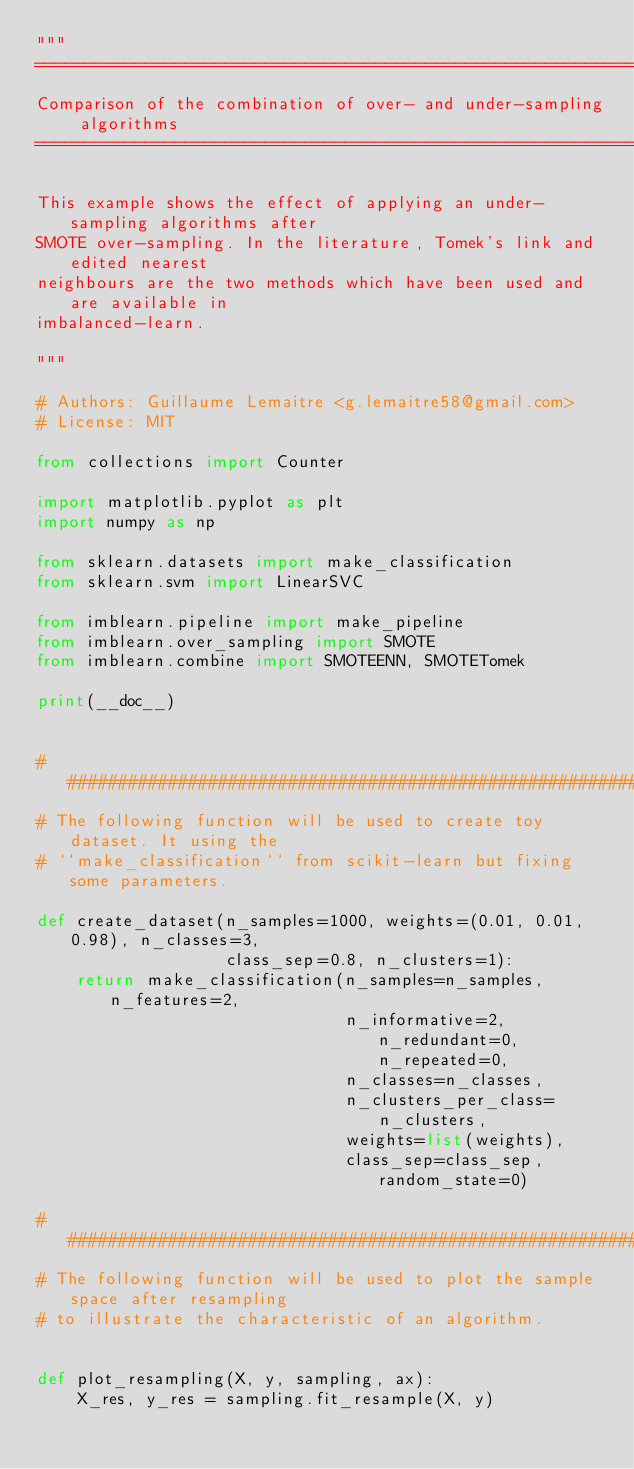Convert code to text. <code><loc_0><loc_0><loc_500><loc_500><_Python_>"""
====================================================================
Comparison of the combination of over- and under-sampling algorithms
====================================================================

This example shows the effect of applying an under-sampling algorithms after
SMOTE over-sampling. In the literature, Tomek's link and edited nearest
neighbours are the two methods which have been used and are available in
imbalanced-learn.

"""

# Authors: Guillaume Lemaitre <g.lemaitre58@gmail.com>
# License: MIT

from collections import Counter

import matplotlib.pyplot as plt
import numpy as np

from sklearn.datasets import make_classification
from sklearn.svm import LinearSVC

from imblearn.pipeline import make_pipeline
from imblearn.over_sampling import SMOTE
from imblearn.combine import SMOTEENN, SMOTETomek

print(__doc__)


###############################################################################
# The following function will be used to create toy dataset. It using the
# ``make_classification`` from scikit-learn but fixing some parameters.

def create_dataset(n_samples=1000, weights=(0.01, 0.01, 0.98), n_classes=3,
                   class_sep=0.8, n_clusters=1):
    return make_classification(n_samples=n_samples, n_features=2,
                               n_informative=2, n_redundant=0, n_repeated=0,
                               n_classes=n_classes,
                               n_clusters_per_class=n_clusters,
                               weights=list(weights),
                               class_sep=class_sep, random_state=0)

###############################################################################
# The following function will be used to plot the sample space after resampling
# to illustrate the characteristic of an algorithm.


def plot_resampling(X, y, sampling, ax):
    X_res, y_res = sampling.fit_resample(X, y)</code> 